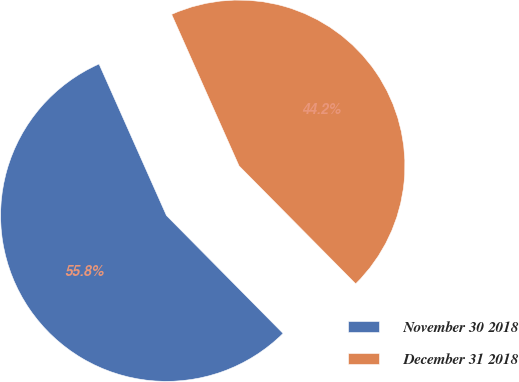Convert chart to OTSL. <chart><loc_0><loc_0><loc_500><loc_500><pie_chart><fcel>November 30 2018<fcel>December 31 2018<nl><fcel>55.75%<fcel>44.25%<nl></chart> 